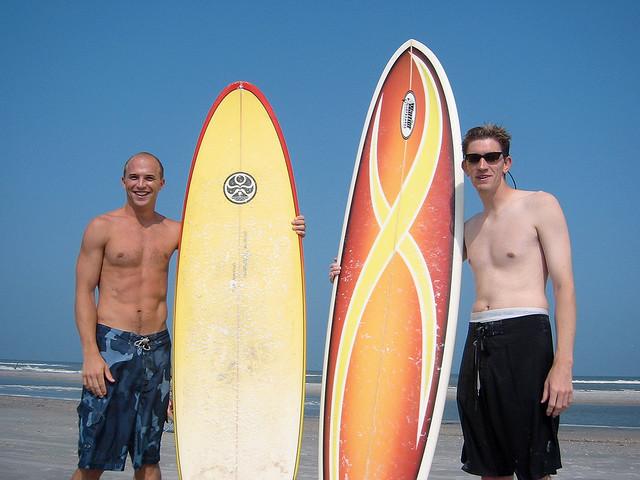What is being advertised on the surfboards?
Answer briefly. Nothing. Which man is taller?
Be succinct. Man on right. Do the men have muscular waist lines?
Give a very brief answer. Yes. What are the special suits the men are wearing called?
Keep it brief. Swim trunks. What color are the surfboards?
Answer briefly. Orange and yellow. Are there surfboards?
Quick response, please. Yes. What color is the board on the right?
Short answer required. Orange. What color is the man's shorts on the right?
Be succinct. Black. 